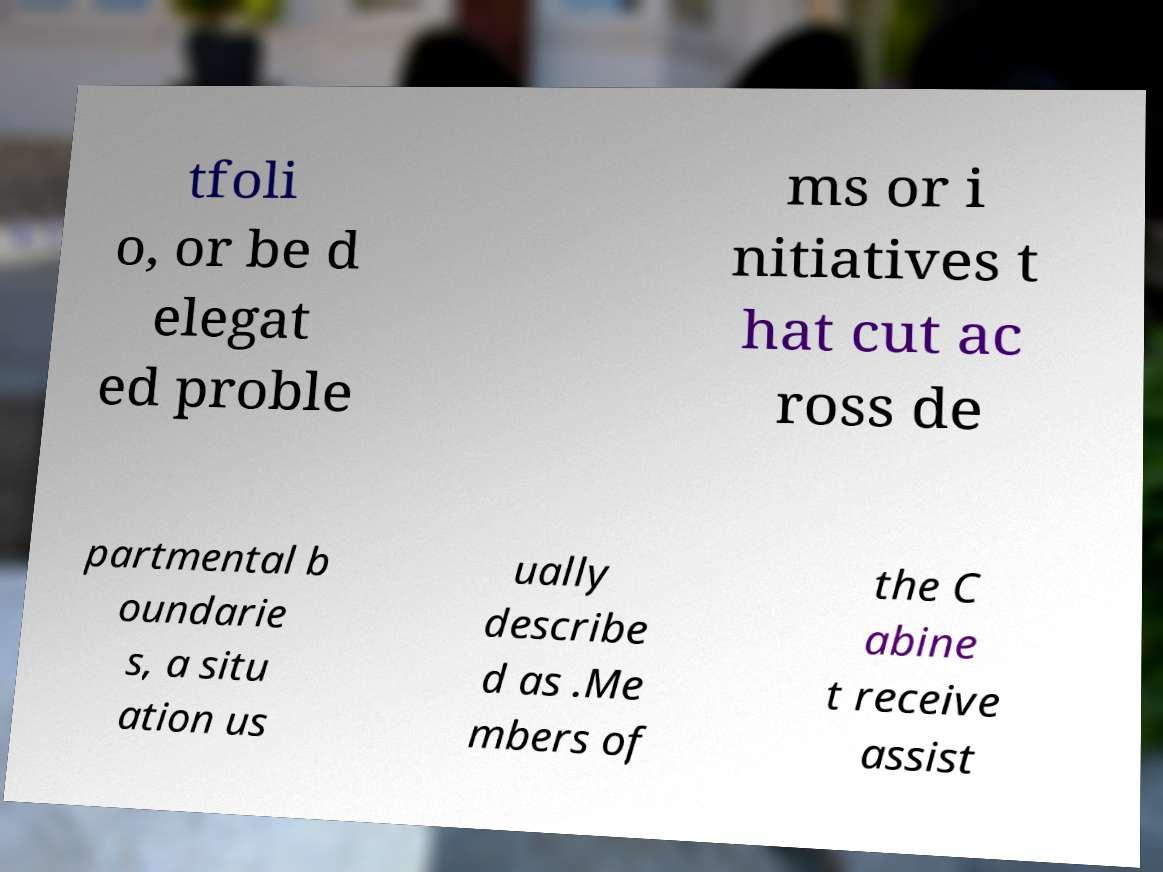I need the written content from this picture converted into text. Can you do that? tfoli o, or be d elegat ed proble ms or i nitiatives t hat cut ac ross de partmental b oundarie s, a situ ation us ually describe d as .Me mbers of the C abine t receive assist 